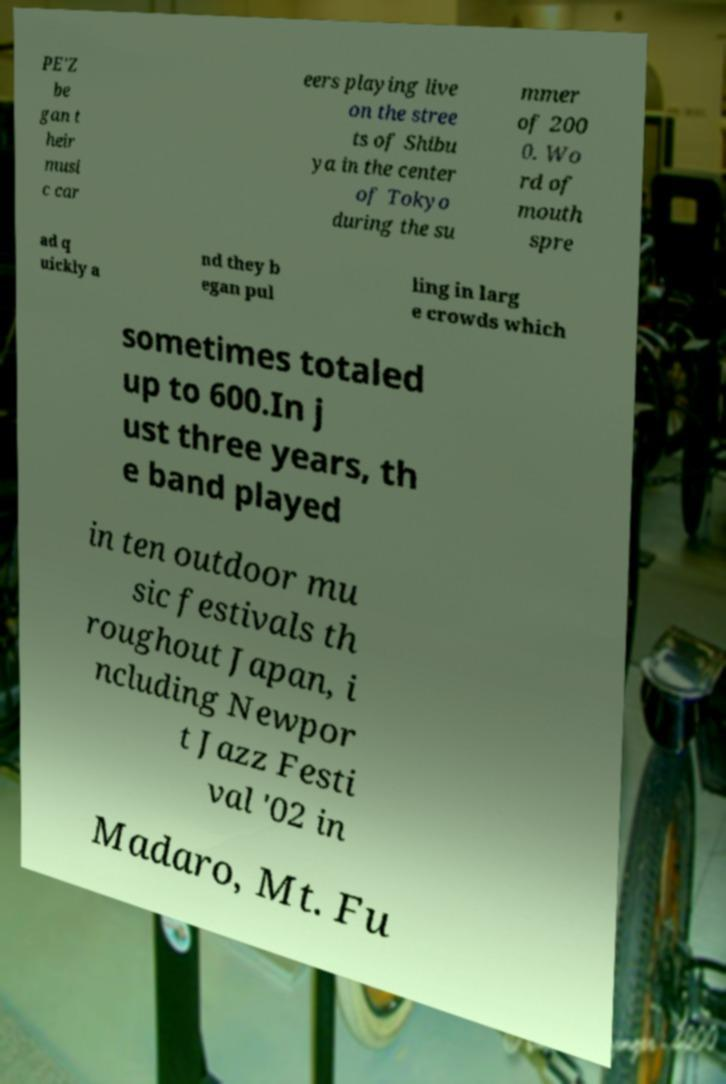Can you accurately transcribe the text from the provided image for me? PE'Z be gan t heir musi c car eers playing live on the stree ts of Shibu ya in the center of Tokyo during the su mmer of 200 0. Wo rd of mouth spre ad q uickly a nd they b egan pul ling in larg e crowds which sometimes totaled up to 600.In j ust three years, th e band played in ten outdoor mu sic festivals th roughout Japan, i ncluding Newpor t Jazz Festi val '02 in Madaro, Mt. Fu 